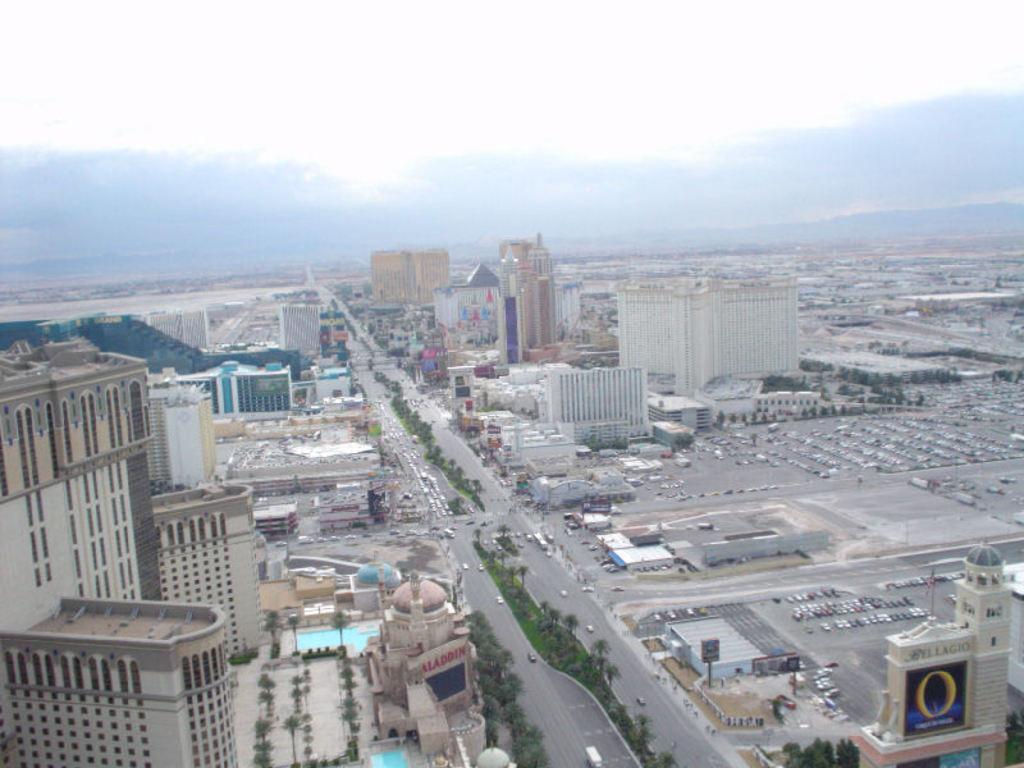How would you summarize this image in a sentence or two? In this image I can see buildings, vehicles, roads, boards, grass, trees, swimming pool, cloudy sky and objects. 